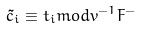Convert formula to latex. <formula><loc_0><loc_0><loc_500><loc_500>\tilde { c } _ { i } \equiv t _ { i } m o d v ^ { - 1 } F ^ { - }</formula> 